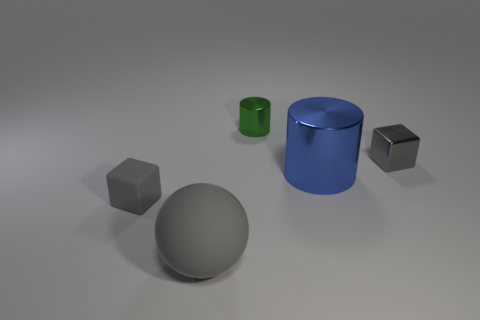Is the number of tiny gray blocks that are on the right side of the small gray metal cube less than the number of metal blocks?
Offer a terse response. Yes. There is a gray object that is the same size as the blue shiny object; what material is it?
Offer a terse response. Rubber. What is the size of the gray object that is on the right side of the matte cube and behind the large gray rubber object?
Keep it short and to the point. Small. What size is the other green metal object that is the same shape as the large metal object?
Offer a very short reply. Small. What number of things are small purple rubber cylinders or gray objects that are to the left of the gray metallic object?
Your response must be concise. 2. What is the shape of the big rubber object?
Provide a short and direct response. Sphere. There is a shiny thing that is in front of the metallic block behind the tiny rubber thing; what shape is it?
Your answer should be very brief. Cylinder. What is the material of the other tiny cube that is the same color as the small metallic block?
Make the answer very short. Rubber. What is the color of the other cylinder that is made of the same material as the tiny green cylinder?
Provide a succinct answer. Blue. Is there anything else that is the same size as the gray ball?
Your answer should be compact. Yes. 